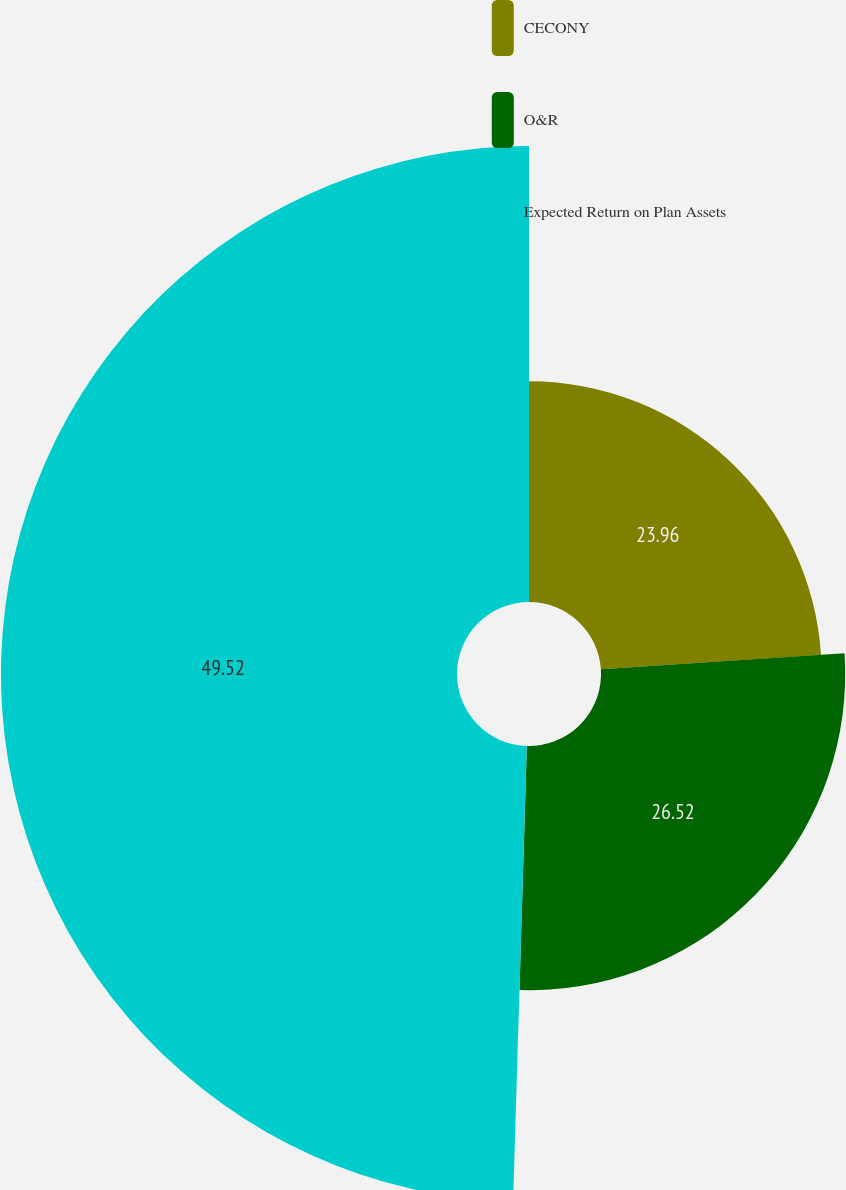Convert chart. <chart><loc_0><loc_0><loc_500><loc_500><pie_chart><fcel>CECONY<fcel>O&R<fcel>Expected Return on Plan Assets<nl><fcel>23.96%<fcel>26.52%<fcel>49.52%<nl></chart> 